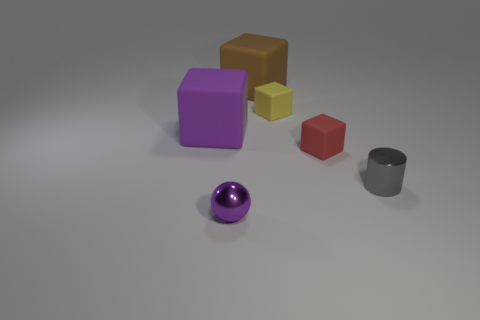Subtract all red rubber cubes. How many cubes are left? 3 Subtract all yellow blocks. How many blocks are left? 3 Subtract all spheres. How many objects are left? 5 Add 1 gray matte balls. How many objects exist? 7 Add 5 tiny gray cylinders. How many tiny gray cylinders are left? 6 Add 4 big blue rubber things. How many big blue rubber things exist? 4 Subtract 0 cyan blocks. How many objects are left? 6 Subtract 3 blocks. How many blocks are left? 1 Subtract all yellow cylinders. Subtract all purple cubes. How many cylinders are left? 1 Subtract all red cubes. How many cyan cylinders are left? 0 